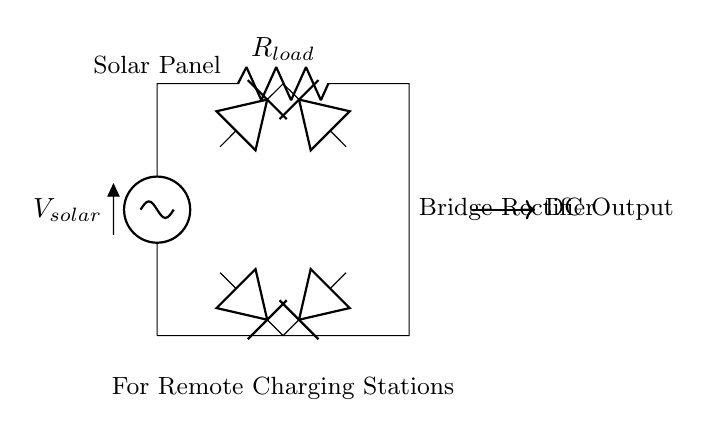What is the function of the solar panel in this circuit? The solar panel generates voltage, providing the energy source for the rectifier circuit.
Answer: energy source How many diodes are used in the bridge rectifier? There are four diodes, as indicated in the structure of the bridge rectifier.
Answer: four What type of load is indicated in the circuit? The load indicated is a resistor, denoted by the symbol R.
Answer: resistor What is the role of the bridge rectifier in this circuit? The bridge rectifier converts alternating current from the solar panel into direct current for charging applications.
Answer: convert AC to DC What does the output from the bridge rectifier represent? The output provides direct current, suitable for charging the connected devices in remote locations.
Answer: direct current Why is a bridge rectifier preferred for solar charging stations? A bridge rectifier efficiently utilizes both halves of the AC waveform, improving power conversion from the solar panel to the load.
Answer: efficient power conversion 